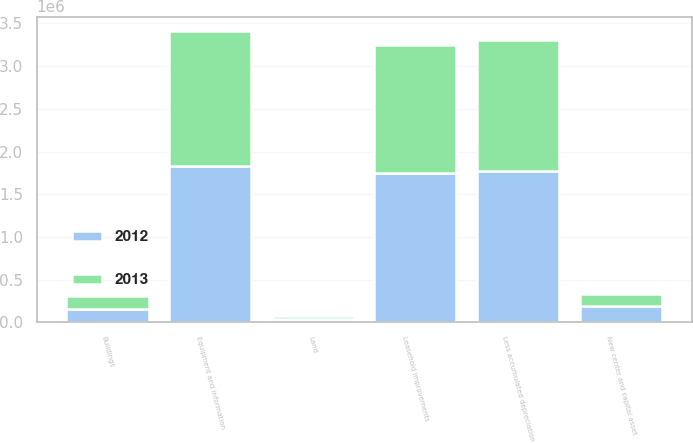Convert chart. <chart><loc_0><loc_0><loc_500><loc_500><stacked_bar_chart><ecel><fcel>Land<fcel>Buildings<fcel>Leasehold improvements<fcel>Equipment and information<fcel>New center and capital asset<fcel>Less accumulated depreciation<nl><fcel>2012<fcel>34960<fcel>157998<fcel>1.74963e+06<fcel>1.83222e+06<fcel>192859<fcel>1.77826e+06<nl><fcel>2013<fcel>35633<fcel>148881<fcel>1.49468e+06<fcel>1.57798e+06<fcel>137387<fcel>1.52218e+06<nl></chart> 